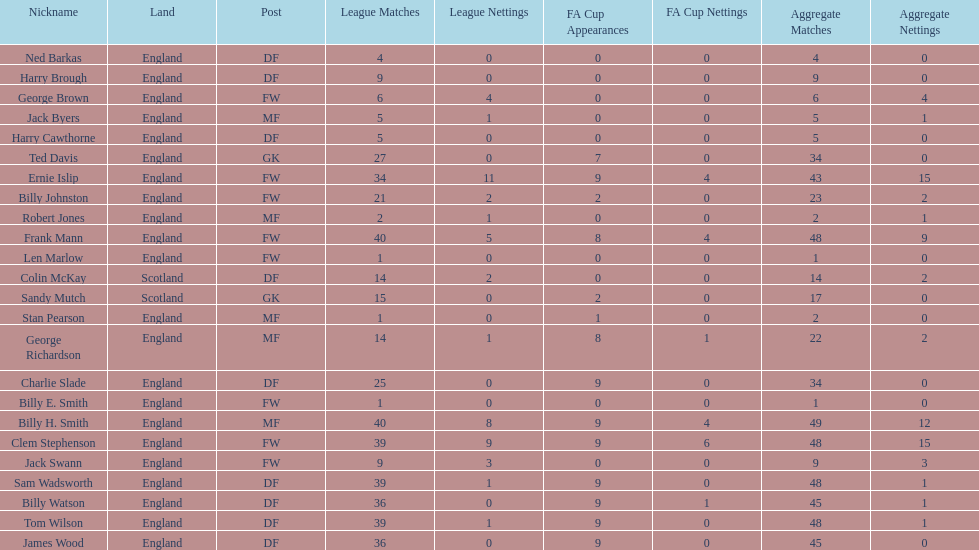How many players are fws? 8. 